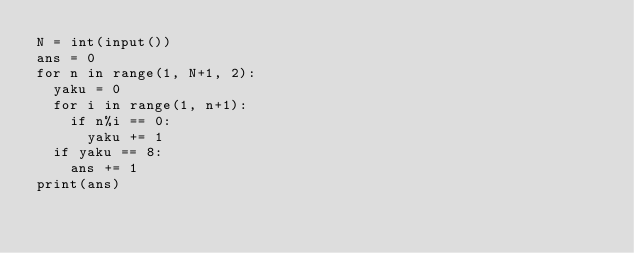<code> <loc_0><loc_0><loc_500><loc_500><_Python_>N = int(input())
ans = 0
for n in range(1, N+1, 2):
  yaku = 0
  for i in range(1, n+1):
    if n%i == 0:
      yaku += 1
  if yaku == 8:
    ans += 1
print(ans)</code> 